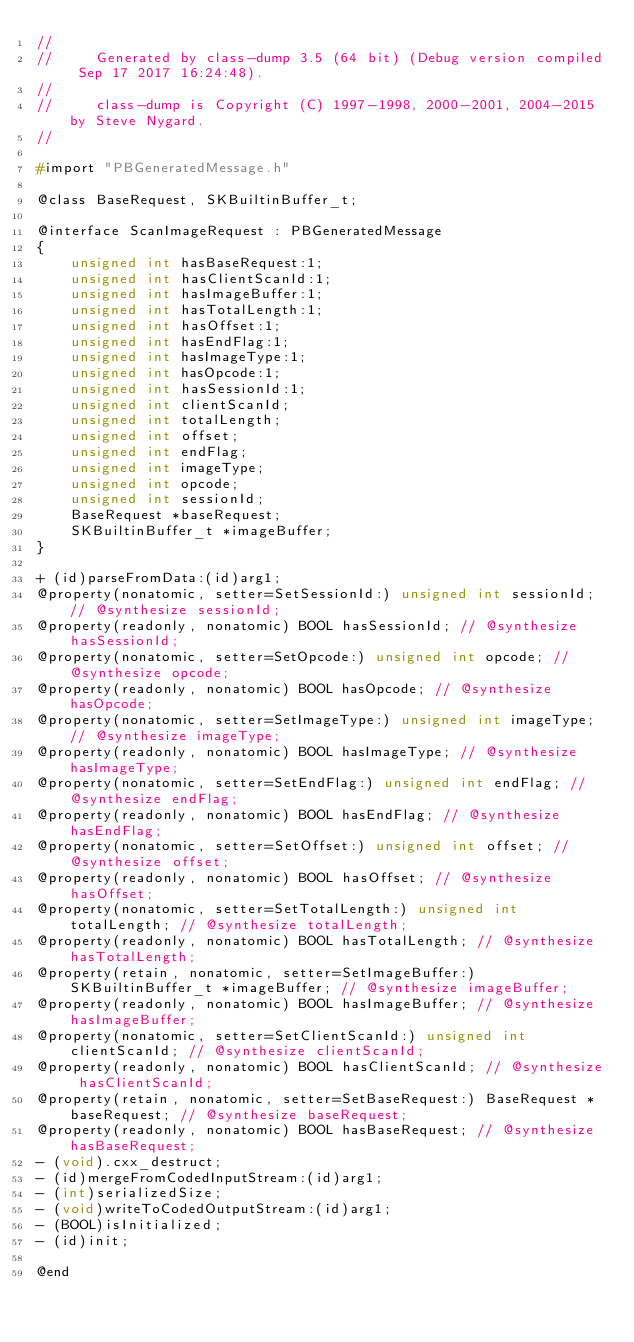Convert code to text. <code><loc_0><loc_0><loc_500><loc_500><_C_>//
//     Generated by class-dump 3.5 (64 bit) (Debug version compiled Sep 17 2017 16:24:48).
//
//     class-dump is Copyright (C) 1997-1998, 2000-2001, 2004-2015 by Steve Nygard.
//

#import "PBGeneratedMessage.h"

@class BaseRequest, SKBuiltinBuffer_t;

@interface ScanImageRequest : PBGeneratedMessage
{
    unsigned int hasBaseRequest:1;
    unsigned int hasClientScanId:1;
    unsigned int hasImageBuffer:1;
    unsigned int hasTotalLength:1;
    unsigned int hasOffset:1;
    unsigned int hasEndFlag:1;
    unsigned int hasImageType:1;
    unsigned int hasOpcode:1;
    unsigned int hasSessionId:1;
    unsigned int clientScanId;
    unsigned int totalLength;
    unsigned int offset;
    unsigned int endFlag;
    unsigned int imageType;
    unsigned int opcode;
    unsigned int sessionId;
    BaseRequest *baseRequest;
    SKBuiltinBuffer_t *imageBuffer;
}

+ (id)parseFromData:(id)arg1;
@property(nonatomic, setter=SetSessionId:) unsigned int sessionId; // @synthesize sessionId;
@property(readonly, nonatomic) BOOL hasSessionId; // @synthesize hasSessionId;
@property(nonatomic, setter=SetOpcode:) unsigned int opcode; // @synthesize opcode;
@property(readonly, nonatomic) BOOL hasOpcode; // @synthesize hasOpcode;
@property(nonatomic, setter=SetImageType:) unsigned int imageType; // @synthesize imageType;
@property(readonly, nonatomic) BOOL hasImageType; // @synthesize hasImageType;
@property(nonatomic, setter=SetEndFlag:) unsigned int endFlag; // @synthesize endFlag;
@property(readonly, nonatomic) BOOL hasEndFlag; // @synthesize hasEndFlag;
@property(nonatomic, setter=SetOffset:) unsigned int offset; // @synthesize offset;
@property(readonly, nonatomic) BOOL hasOffset; // @synthesize hasOffset;
@property(nonatomic, setter=SetTotalLength:) unsigned int totalLength; // @synthesize totalLength;
@property(readonly, nonatomic) BOOL hasTotalLength; // @synthesize hasTotalLength;
@property(retain, nonatomic, setter=SetImageBuffer:) SKBuiltinBuffer_t *imageBuffer; // @synthesize imageBuffer;
@property(readonly, nonatomic) BOOL hasImageBuffer; // @synthesize hasImageBuffer;
@property(nonatomic, setter=SetClientScanId:) unsigned int clientScanId; // @synthesize clientScanId;
@property(readonly, nonatomic) BOOL hasClientScanId; // @synthesize hasClientScanId;
@property(retain, nonatomic, setter=SetBaseRequest:) BaseRequest *baseRequest; // @synthesize baseRequest;
@property(readonly, nonatomic) BOOL hasBaseRequest; // @synthesize hasBaseRequest;
- (void).cxx_destruct;
- (id)mergeFromCodedInputStream:(id)arg1;
- (int)serializedSize;
- (void)writeToCodedOutputStream:(id)arg1;
- (BOOL)isInitialized;
- (id)init;

@end

</code> 